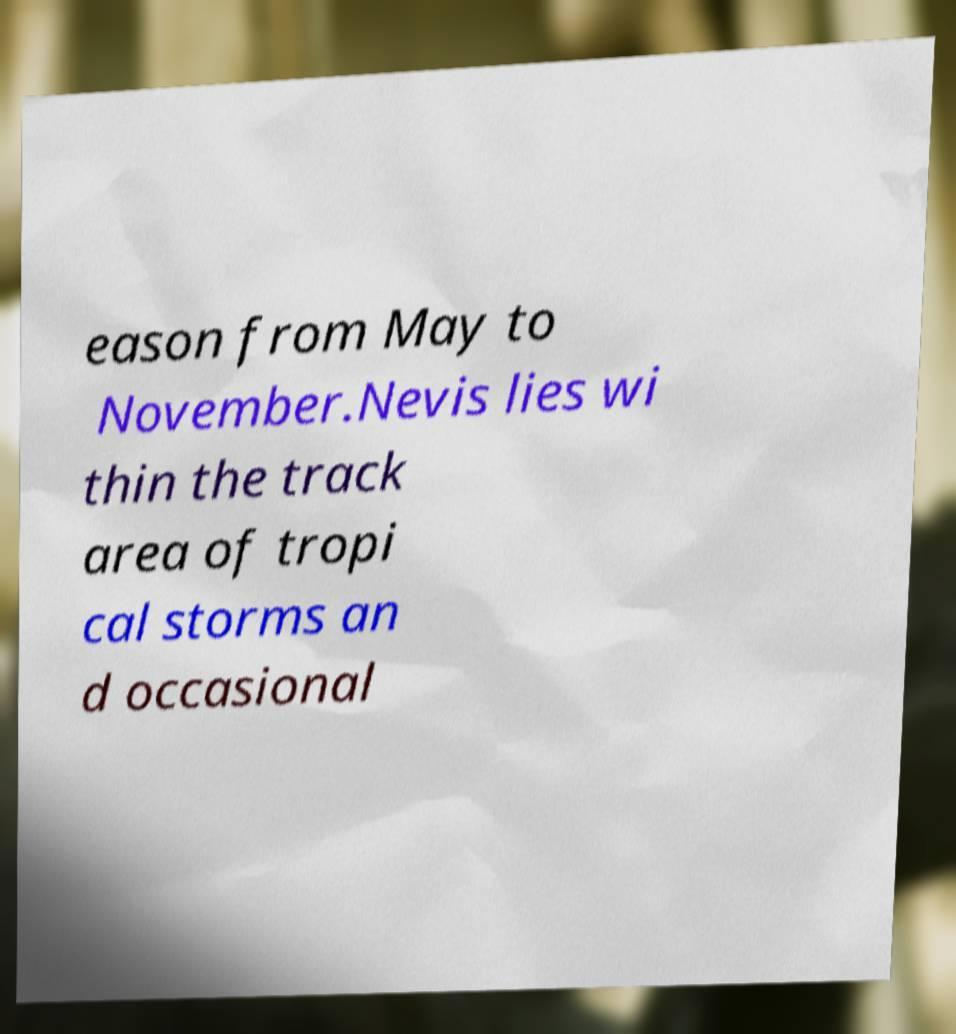There's text embedded in this image that I need extracted. Can you transcribe it verbatim? eason from May to November.Nevis lies wi thin the track area of tropi cal storms an d occasional 